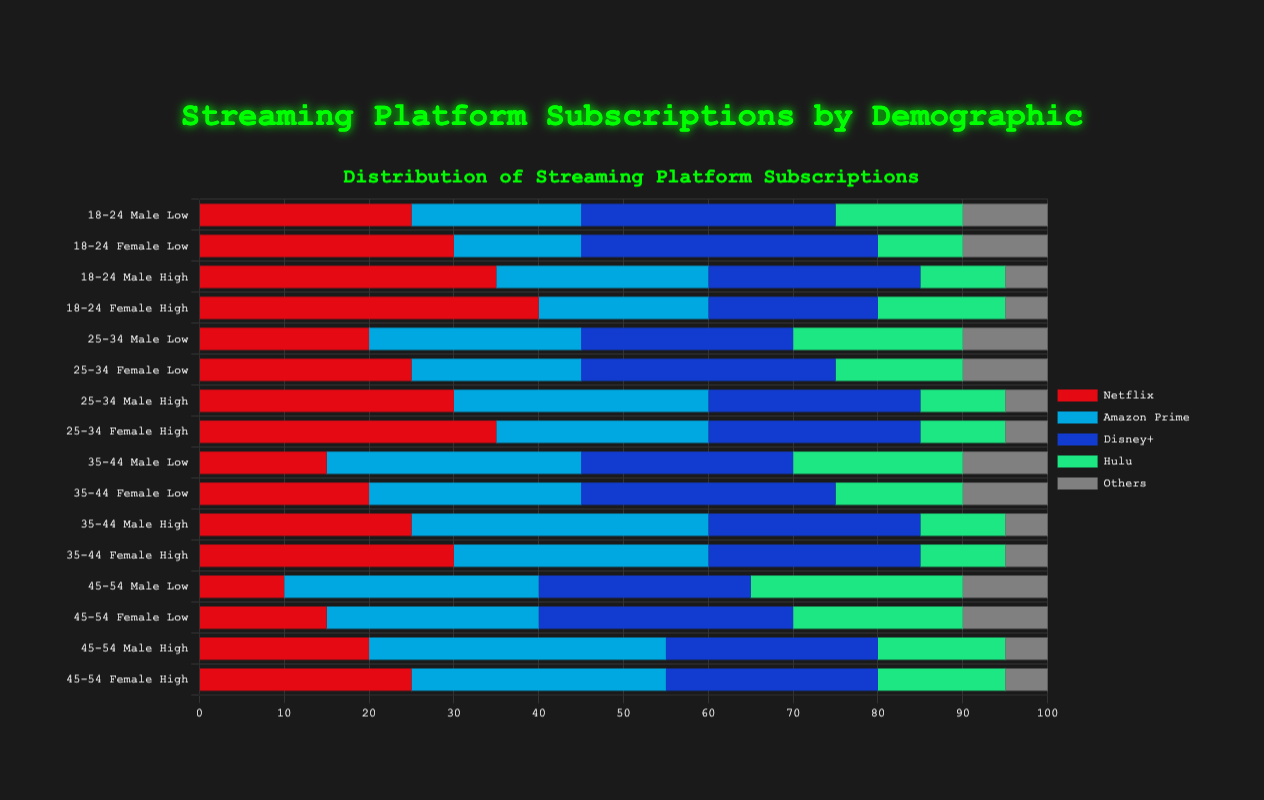What's the total number of subscriptions for the 18-24 age group, low-income females? Sum the values for Netflix, Amazon Prime, Disney+, Hulu, and Others for the 18-24 age group, low-income females: 30 (Netflix) + 15 (Amazon Prime) + 35 (Disney+) + 10 (Hulu) + 10 (Others) = 100
Answer: 100 Which group has the least number of 'Others' subscriptions? Compare the 'Others' subscription values across all demographic groups. The 18-24 age group, high-income males, and 18-24 age group, high-income females both have the minimum value of 5.
Answer: 18-24 age group, high-income males and 18-24 age group, high-income females Who subscribes to Netflix more, the 35-44 age group, high-income males, or the 45-54 age group, high-income females? Compare the Netflix values for the two groups: 35 (35-44 high-income males) vs. 25 (45-54 high-income females).
Answer: 35-44 age group, high-income males Which subscription service is most popular among the 25-34 age group, low-income males? Look at the values for Netflix, Amazon Prime, Disney+, Hulu, and Others for this group and identify the highest value, which is Disney+ with 25 subscriptions.
Answer: Disney+ Between the 35-44 age group and 45-54 age group, low-income males, which group has a higher Amazon Prime subscription count? Compare the Amazon Prime values: 30 (35-44 low-income males) vs. 30 (45-54 low-income males). Both groups have the same count.
Answer: Equal What's the difference in Disney+ subscriptions between 18-24 age group, high-income females, and 25-34 age group, high-income males? Subtract the Disney+ value of the 25-34 age group, high-income males from that of the 18-24 age group, high-income females: 20 (18-24 high-income females) - 25 (25-34 high-income males) = -5
Answer: -5 Which streaming service shows the least variation in subscription counts across all demographic groups? Calculate the spread (max - min) for each streaming service: Netflix (40 - 10 = 30), Amazon Prime (35 - 15 = 20), Disney+ (35 - 20 = 15), Hulu (25 - 15 = 10), Others (10 - 5 = 5). The smallest spread is for 'Others' with a variation of 5 subscriptions.
Answer: Others 